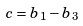<formula> <loc_0><loc_0><loc_500><loc_500>c = b _ { 1 } - b _ { 3 }</formula> 